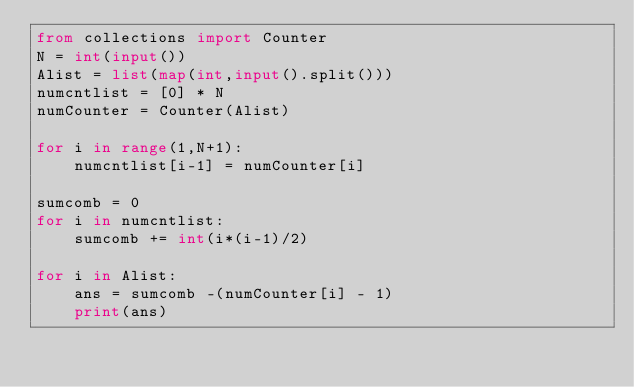<code> <loc_0><loc_0><loc_500><loc_500><_Python_>from collections import Counter
N = int(input())
Alist = list(map(int,input().split()))
numcntlist = [0] * N 
numCounter = Counter(Alist)

for i in range(1,N+1):
    numcntlist[i-1] = numCounter[i]

sumcomb = 0
for i in numcntlist:
    sumcomb += int(i*(i-1)/2)

for i in Alist:
    ans = sumcomb -(numCounter[i] - 1)
    print(ans)</code> 